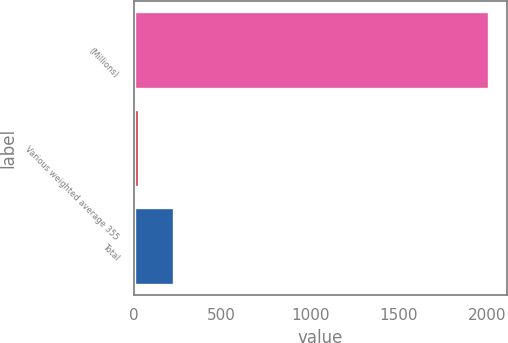Convert chart. <chart><loc_0><loc_0><loc_500><loc_500><bar_chart><fcel>(Millions)<fcel>Various weighted average 355<fcel>Total<nl><fcel>2013<fcel>30<fcel>228.3<nl></chart> 